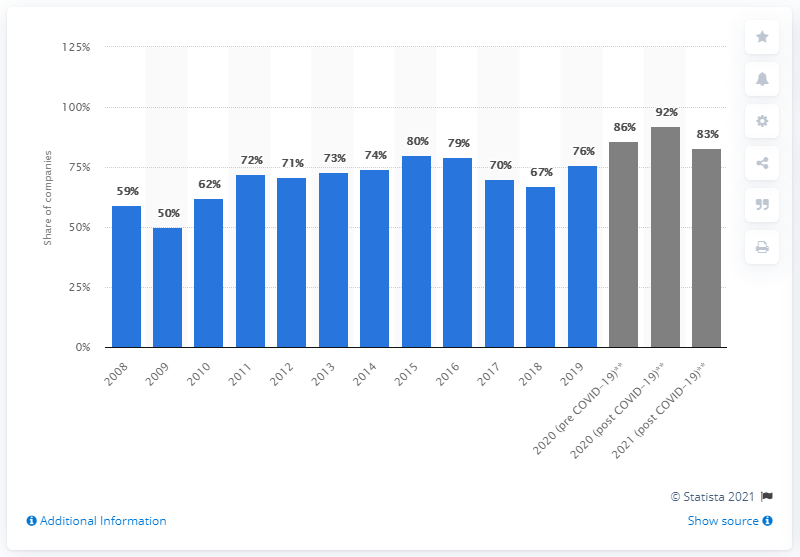Identify some key points in this picture. According to a survey, 92% of companies stated that they plan to hire MBA graduates in 2020. 